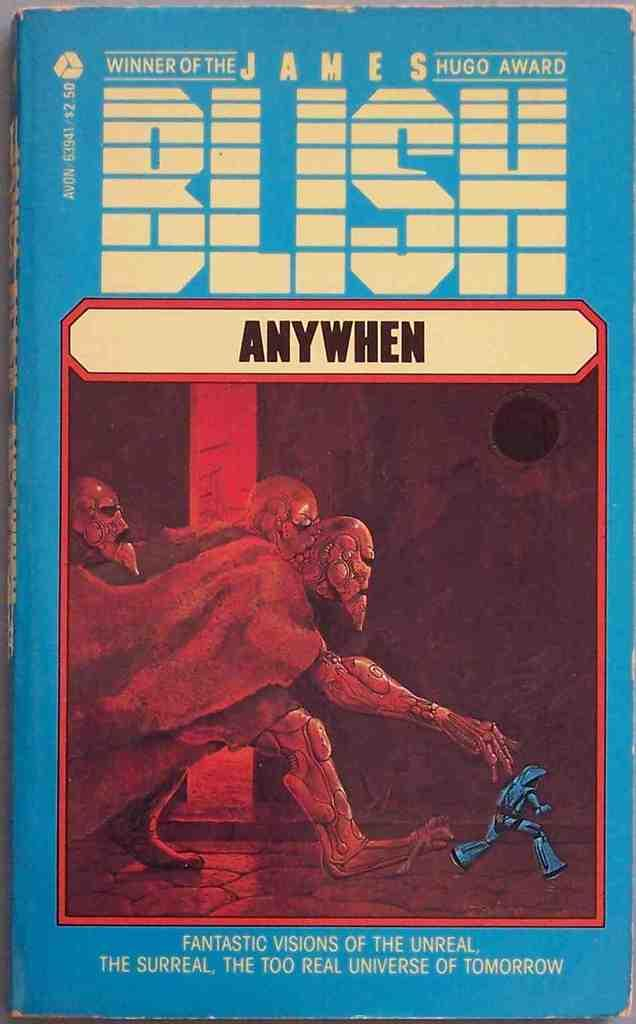<image>
Provide a brief description of the given image. A book by James Blish called AnyWhen, with a blue cover. 